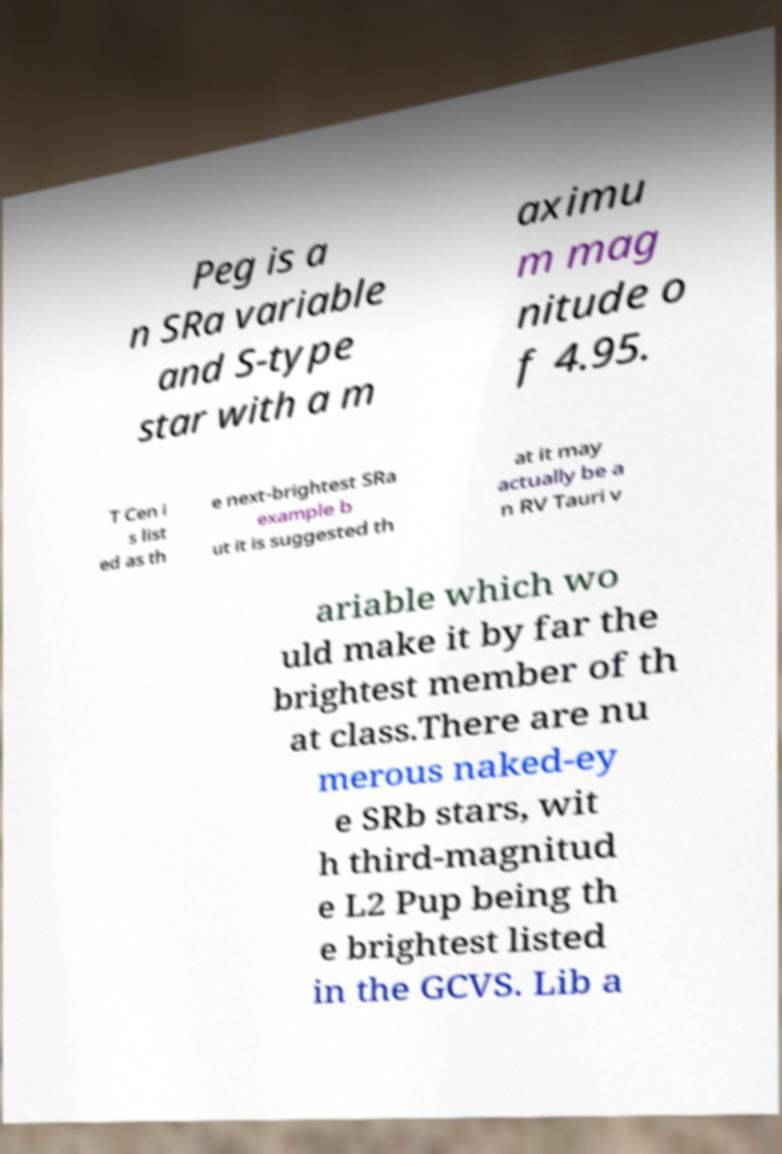Please identify and transcribe the text found in this image. Peg is a n SRa variable and S-type star with a m aximu m mag nitude o f 4.95. T Cen i s list ed as th e next-brightest SRa example b ut it is suggested th at it may actually be a n RV Tauri v ariable which wo uld make it by far the brightest member of th at class.There are nu merous naked-ey e SRb stars, wit h third-magnitud e L2 Pup being th e brightest listed in the GCVS. Lib a 